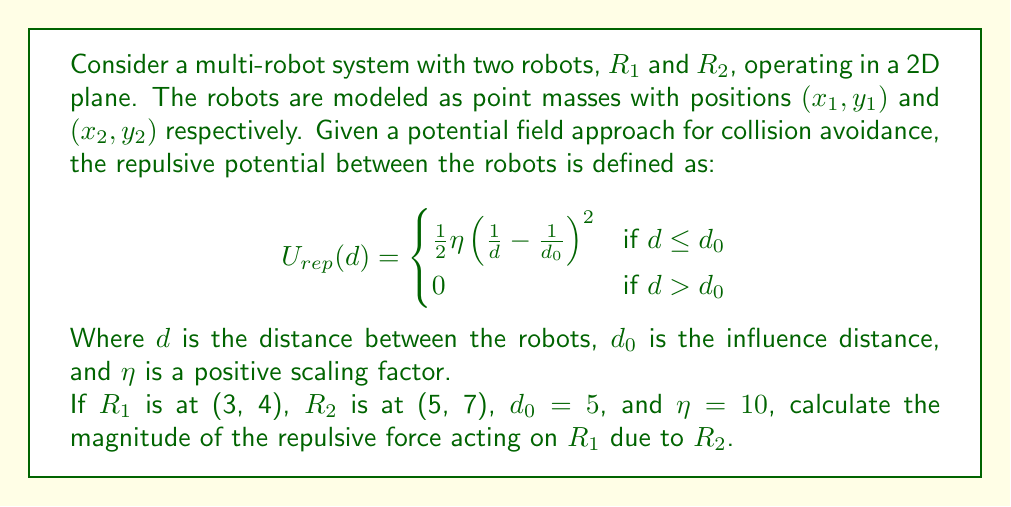Provide a solution to this math problem. To solve this problem, we'll follow these steps:

1) Calculate the distance $d$ between the robots:
   $$d = \sqrt{(x_2-x_1)^2 + (y_2-y_1)^2} = \sqrt{(5-3)^2 + (7-4)^2} = \sqrt{4 + 9} = \sqrt{13} \approx 3.61$$

2) Check if $d \leq d_0$:
   $3.61 < 5$, so we use the repulsive potential formula.

3) Calculate the repulsive potential:
   $$U_{rep}(d) = \frac{1}{2} \eta \left(\frac{1}{d} - \frac{1}{d_0}\right)^2$$
   $$U_{rep}(3.61) = \frac{1}{2} \cdot 10 \left(\frac{1}{3.61} - \frac{1}{5}\right)^2 \approx 0.0389$$

4) The repulsive force is the negative gradient of the potential:
   $$\mathbf{F}_{rep} = -\nabla U_{rep} = -\frac{\partial U_{rep}}{\partial d} \cdot \frac{\mathbf{r}}{d}$$
   Where $\mathbf{r}$ is the vector from $R_1$ to $R_2$.

5) Calculate $\frac{\partial U_{rep}}{\partial d}$:
   $$\frac{\partial U_{rep}}{\partial d} = -\eta \left(\frac{1}{d} - \frac{1}{d_0}\right) \cdot \frac{1}{d^2}$$
   $$\frac{\partial U_{rep}}{\partial d} = -10 \left(\frac{1}{3.61} - \frac{1}{5}\right) \cdot \frac{1}{3.61^2} \approx -0.0299$$

6) The magnitude of the repulsive force is:
   $$|\mathbf{F}_{rep}| = \left|-\frac{\partial U_{rep}}{\partial d}\right| \approx 0.0299$$
Answer: $|\mathbf{F}_{rep}| \approx 0.0299$ 